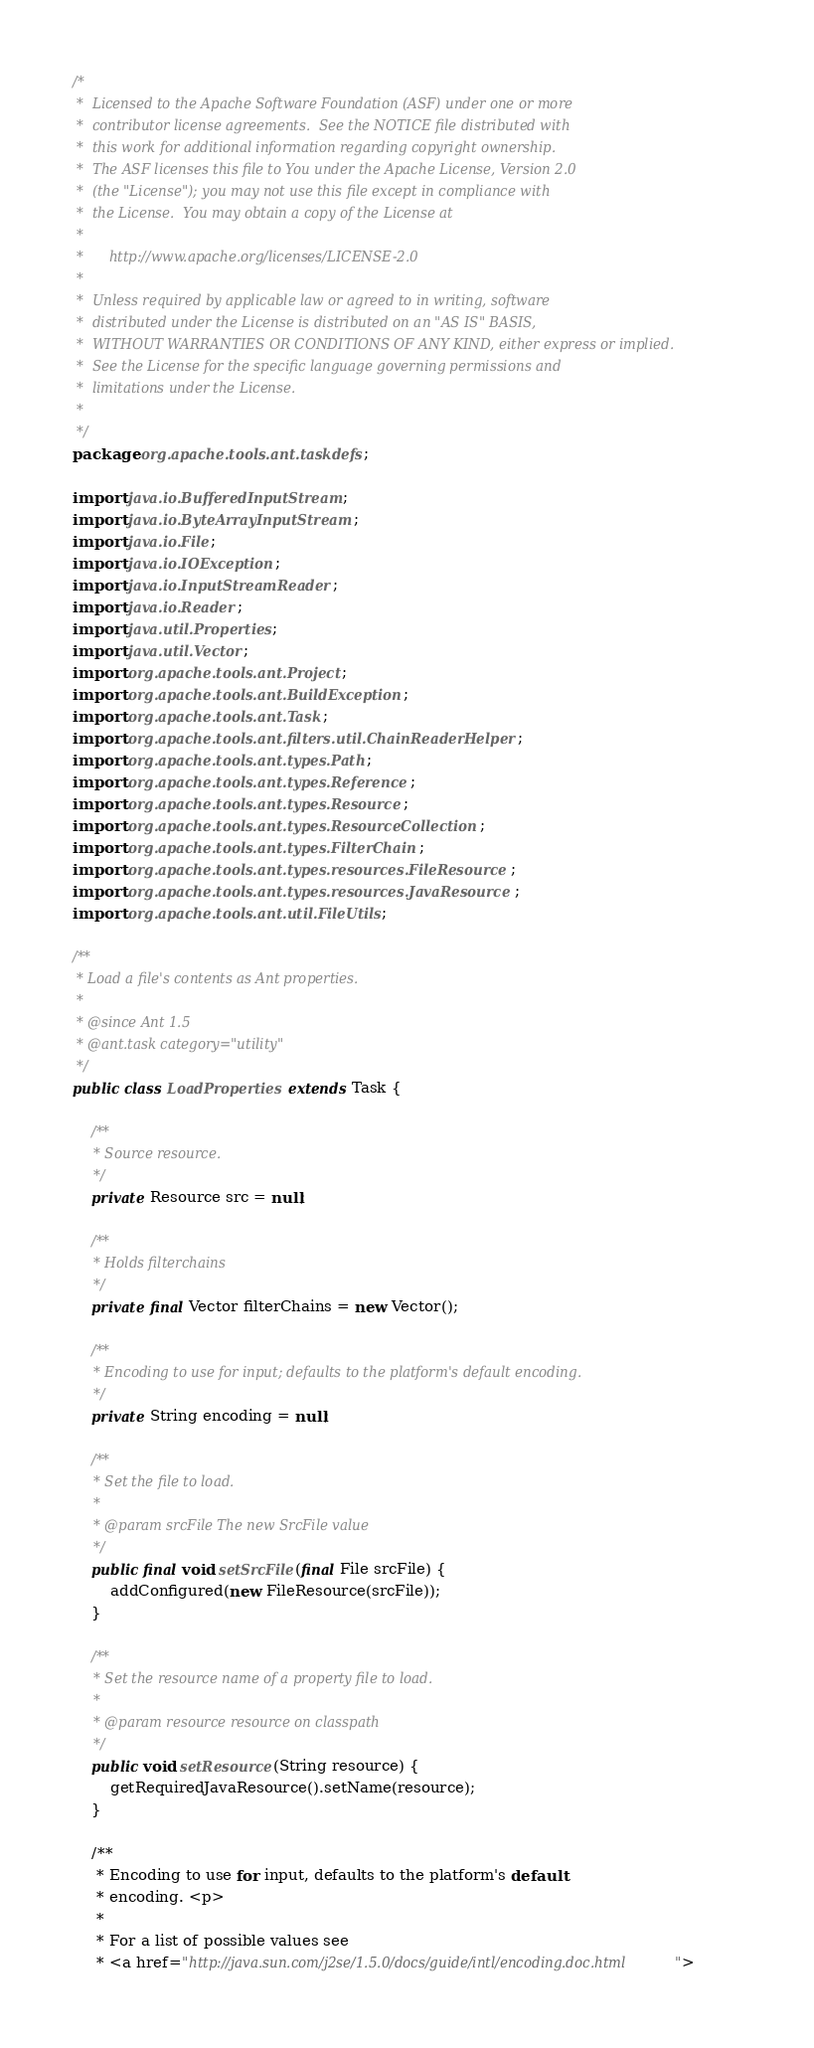Convert code to text. <code><loc_0><loc_0><loc_500><loc_500><_Java_>/*
 *  Licensed to the Apache Software Foundation (ASF) under one or more
 *  contributor license agreements.  See the NOTICE file distributed with
 *  this work for additional information regarding copyright ownership.
 *  The ASF licenses this file to You under the Apache License, Version 2.0
 *  (the "License"); you may not use this file except in compliance with
 *  the License.  You may obtain a copy of the License at
 *
 *      http://www.apache.org/licenses/LICENSE-2.0
 *
 *  Unless required by applicable law or agreed to in writing, software
 *  distributed under the License is distributed on an "AS IS" BASIS,
 *  WITHOUT WARRANTIES OR CONDITIONS OF ANY KIND, either express or implied.
 *  See the License for the specific language governing permissions and
 *  limitations under the License.
 *
 */
package org.apache.tools.ant.taskdefs;

import java.io.BufferedInputStream;
import java.io.ByteArrayInputStream;
import java.io.File;
import java.io.IOException;
import java.io.InputStreamReader;
import java.io.Reader;
import java.util.Properties;
import java.util.Vector;
import org.apache.tools.ant.Project;
import org.apache.tools.ant.BuildException;
import org.apache.tools.ant.Task;
import org.apache.tools.ant.filters.util.ChainReaderHelper;
import org.apache.tools.ant.types.Path;
import org.apache.tools.ant.types.Reference;
import org.apache.tools.ant.types.Resource;
import org.apache.tools.ant.types.ResourceCollection;
import org.apache.tools.ant.types.FilterChain;
import org.apache.tools.ant.types.resources.FileResource;
import org.apache.tools.ant.types.resources.JavaResource;
import org.apache.tools.ant.util.FileUtils;

/**
 * Load a file's contents as Ant properties.
 *
 * @since Ant 1.5
 * @ant.task category="utility"
 */
public class LoadProperties extends Task {

    /**
     * Source resource.
     */
    private Resource src = null;

    /**
     * Holds filterchains
     */
    private final Vector filterChains = new Vector();

    /**
     * Encoding to use for input; defaults to the platform's default encoding.
     */
    private String encoding = null;

    /**
     * Set the file to load.
     *
     * @param srcFile The new SrcFile value
     */
    public final void setSrcFile(final File srcFile) {
        addConfigured(new FileResource(srcFile));
    }

    /**
     * Set the resource name of a property file to load.
     *
     * @param resource resource on classpath
     */
    public void setResource(String resource) {
        getRequiredJavaResource().setName(resource);
    }

    /**
     * Encoding to use for input, defaults to the platform's default
     * encoding. <p>
     *
     * For a list of possible values see
     * <a href="http://java.sun.com/j2se/1.5.0/docs/guide/intl/encoding.doc.html"></code> 